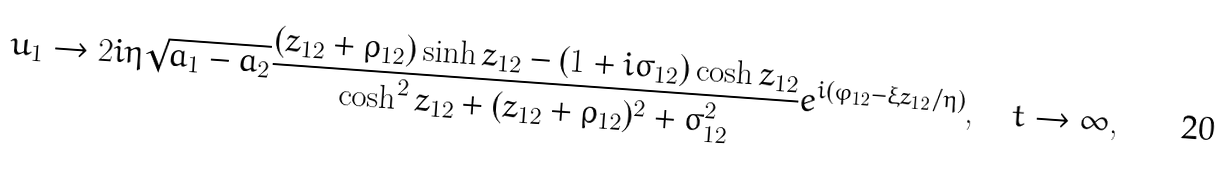Convert formula to latex. <formula><loc_0><loc_0><loc_500><loc_500>u _ { 1 } \rightarrow 2 i \eta \sqrt { a _ { 1 } - a _ { 2 } } \frac { ( z _ { 1 2 } + \varrho _ { 1 2 } ) \sinh { z _ { 1 2 } } - ( 1 + i \sigma _ { 1 2 } ) \cosh { z _ { 1 2 } } } { \cosh ^ { 2 } { z _ { 1 2 } } + ( z _ { 1 2 } + \varrho _ { 1 2 } ) ^ { 2 } + \sigma _ { 1 2 } ^ { 2 } } e ^ { i ( \varphi _ { 1 2 } - \xi z _ { 1 2 } / \eta ) } , \quad t \to \infty ,</formula> 